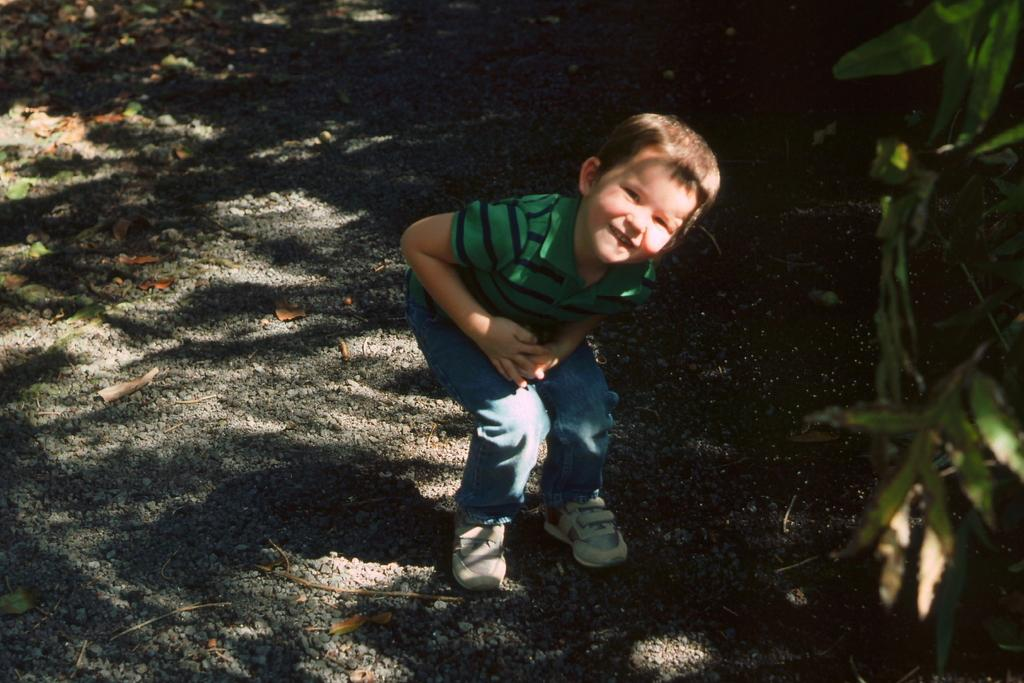What is the main subject of the image? The main subject of the image is a boy. What is the boy doing in the image? The boy is standing on the ground and smiling. What can be seen on the right side of the image? There is a tree on the right side of the image. What type of shoes is the boy wearing in the image? The provided facts do not mention shoes, so we cannot determine the type of shoes the boy is wearing in the image. 